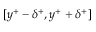Convert formula to latex. <formula><loc_0><loc_0><loc_500><loc_500>[ y ^ { + } - \delta ^ { + } , y ^ { + } + \delta ^ { + } ]</formula> 